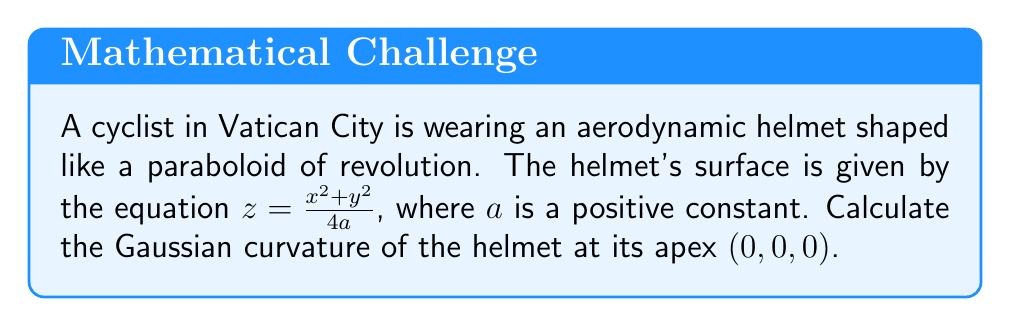Teach me how to tackle this problem. To compute the Gaussian curvature of the cyclist's helmet, we'll follow these steps:

1) The Gaussian curvature K is given by $K = \frac{LN - M^2}{EG - F^2}$, where E, F, G are the coefficients of the first fundamental form, and L, M, N are the coefficients of the second fundamental form.

2) For a surface of the form $z = f(x,y)$, we have:
   $E = 1 + (\frac{\partial f}{\partial x})^2$
   $F = \frac{\partial f}{\partial x} \frac{\partial f}{\partial y}$
   $G = 1 + (\frac{\partial f}{\partial y})^2$
   $L = \frac{\frac{\partial^2 f}{\partial x^2}}{\sqrt{1 + (\frac{\partial f}{\partial x})^2 + (\frac{\partial f}{\partial y})^2}}$
   $M = \frac{\frac{\partial^2 f}{\partial x \partial y}}{\sqrt{1 + (\frac{\partial f}{\partial x})^2 + (\frac{\partial f}{\partial y})^2}}$
   $N = \frac{\frac{\partial^2 f}{\partial y^2}}{\sqrt{1 + (\frac{\partial f}{\partial x})^2 + (\frac{\partial f}{\partial y})^2}}$

3) For our surface, $f(x,y) = \frac{x^2 + y^2}{4a}$. Let's compute the partial derivatives:
   $\frac{\partial f}{\partial x} = \frac{x}{2a}$
   $\frac{\partial f}{\partial y} = \frac{y}{2a}$
   $\frac{\partial^2 f}{\partial x^2} = \frac{1}{2a}$
   $\frac{\partial^2 f}{\partial y^2} = \frac{1}{2a}$
   $\frac{\partial^2 f}{\partial x \partial y} = 0$

4) At the apex (0, 0, 0), these simplify to:
   $\frac{\partial f}{\partial x} = \frac{\partial f}{\partial y} = 0$
   $\frac{\partial^2 f}{\partial x^2} = \frac{\partial^2 f}{\partial y^2} = \frac{1}{2a}$
   $\frac{\partial^2 f}{\partial x \partial y} = 0$

5) Substituting into the formulas for E, F, G, L, M, N at the apex:
   $E = G = 1$, $F = 0$
   $L = N = \frac{1}{2a}$, $M = 0$

6) Now we can compute the Gaussian curvature:
   $K = \frac{LN - M^2}{EG - F^2} = \frac{(\frac{1}{2a})(\frac{1}{2a}) - 0^2}{1 \cdot 1 - 0^2} = \frac{1}{4a^2}$

Therefore, the Gaussian curvature at the apex of the helmet is $\frac{1}{4a^2}$.
Answer: $\frac{1}{4a^2}$ 